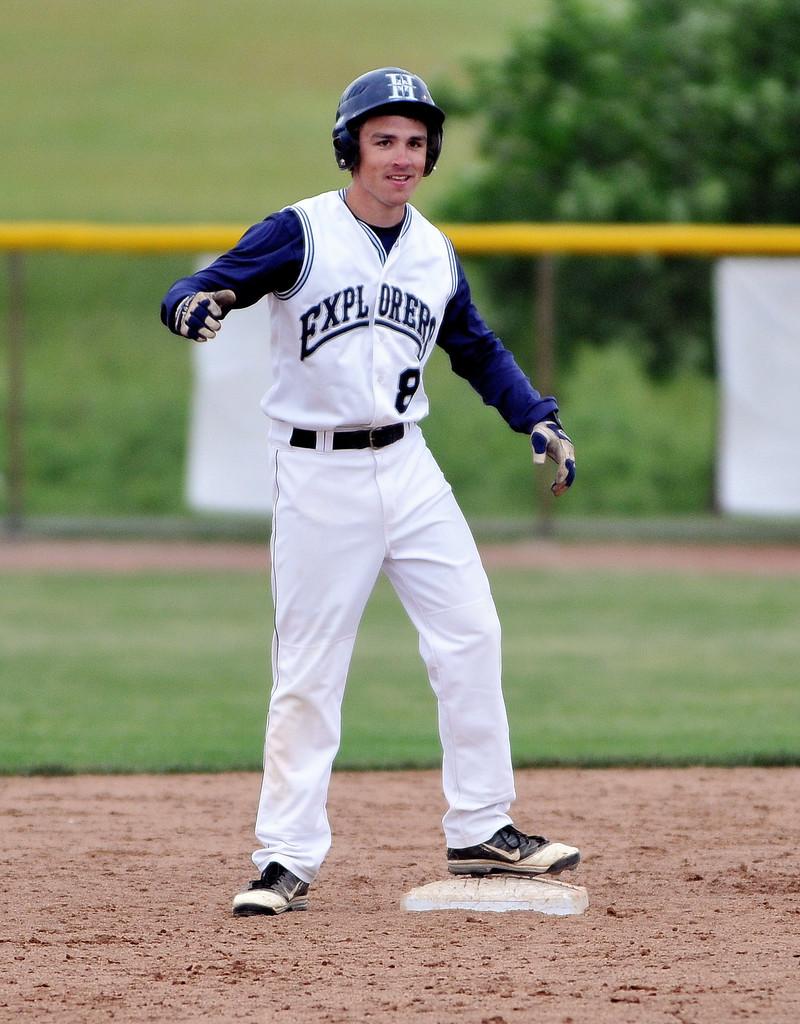What is the team name?
Give a very brief answer. Explorers. What letter is on the helmet?
Provide a succinct answer. H. 